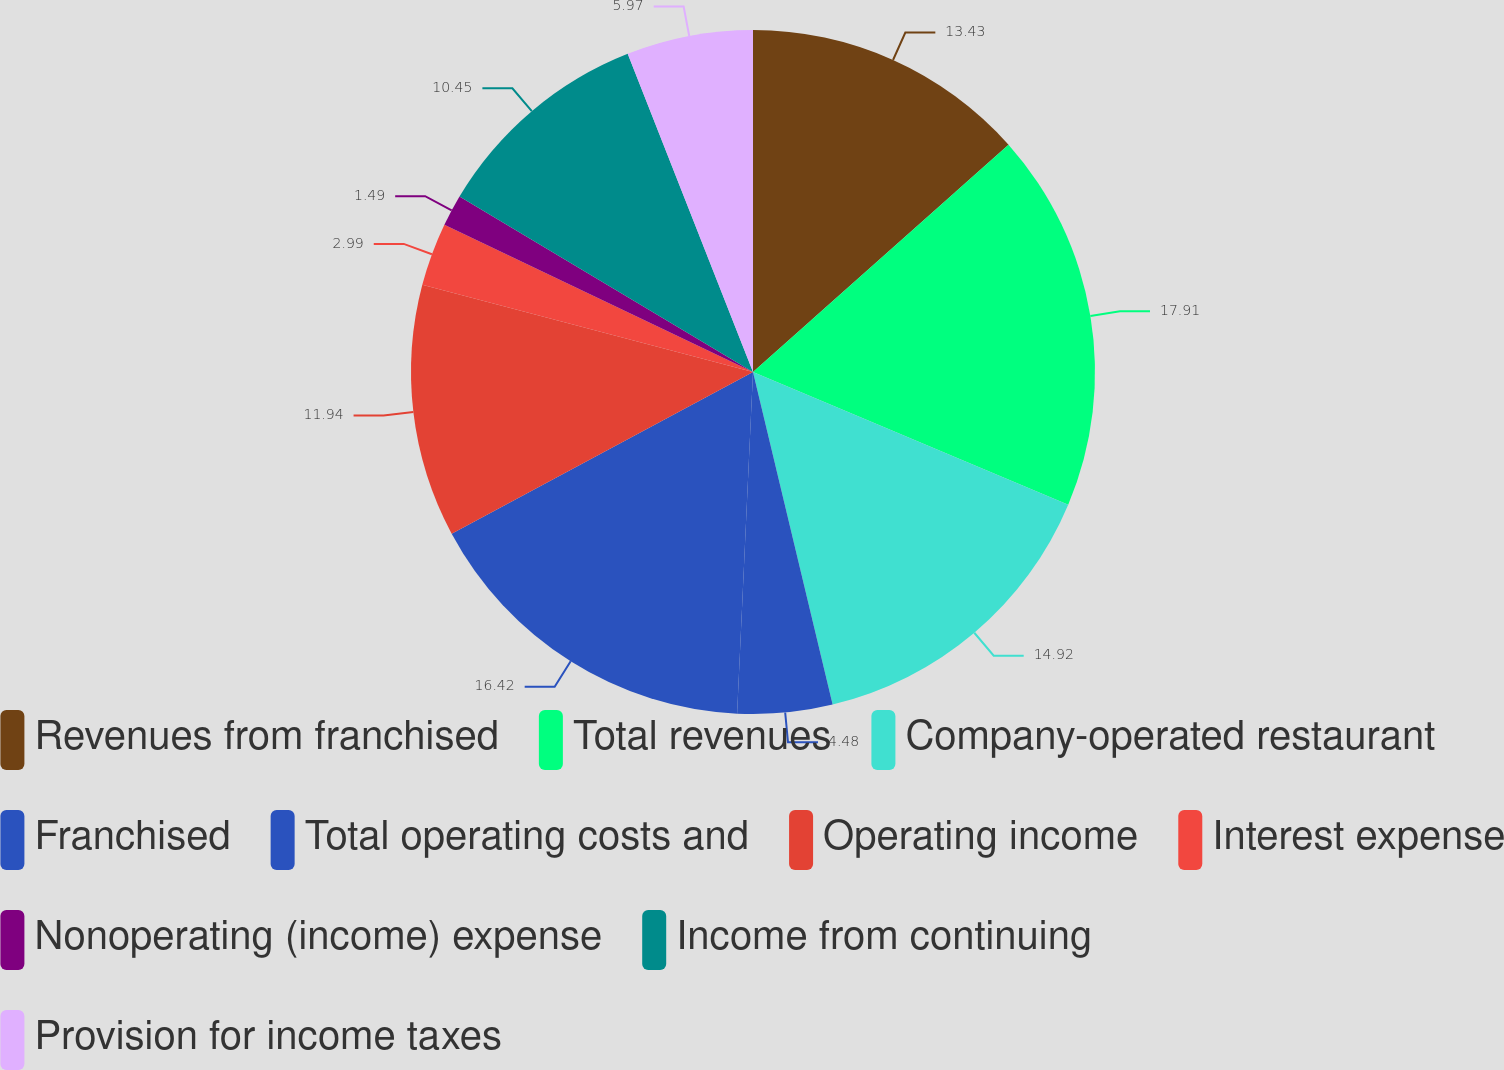<chart> <loc_0><loc_0><loc_500><loc_500><pie_chart><fcel>Revenues from franchised<fcel>Total revenues<fcel>Company-operated restaurant<fcel>Franchised<fcel>Total operating costs and<fcel>Operating income<fcel>Interest expense<fcel>Nonoperating (income) expense<fcel>Income from continuing<fcel>Provision for income taxes<nl><fcel>13.43%<fcel>17.91%<fcel>14.92%<fcel>4.48%<fcel>16.42%<fcel>11.94%<fcel>2.99%<fcel>1.49%<fcel>10.45%<fcel>5.97%<nl></chart> 